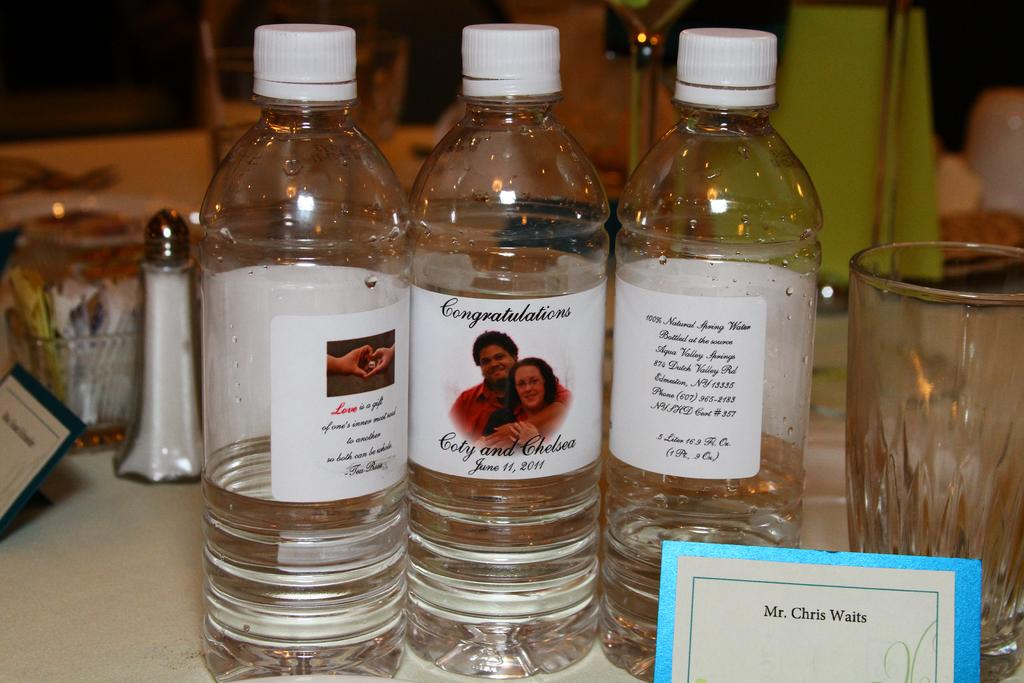<image>
Give a short and clear explanation of the subsequent image. water bottles with a congratulations label sit on display on a table 